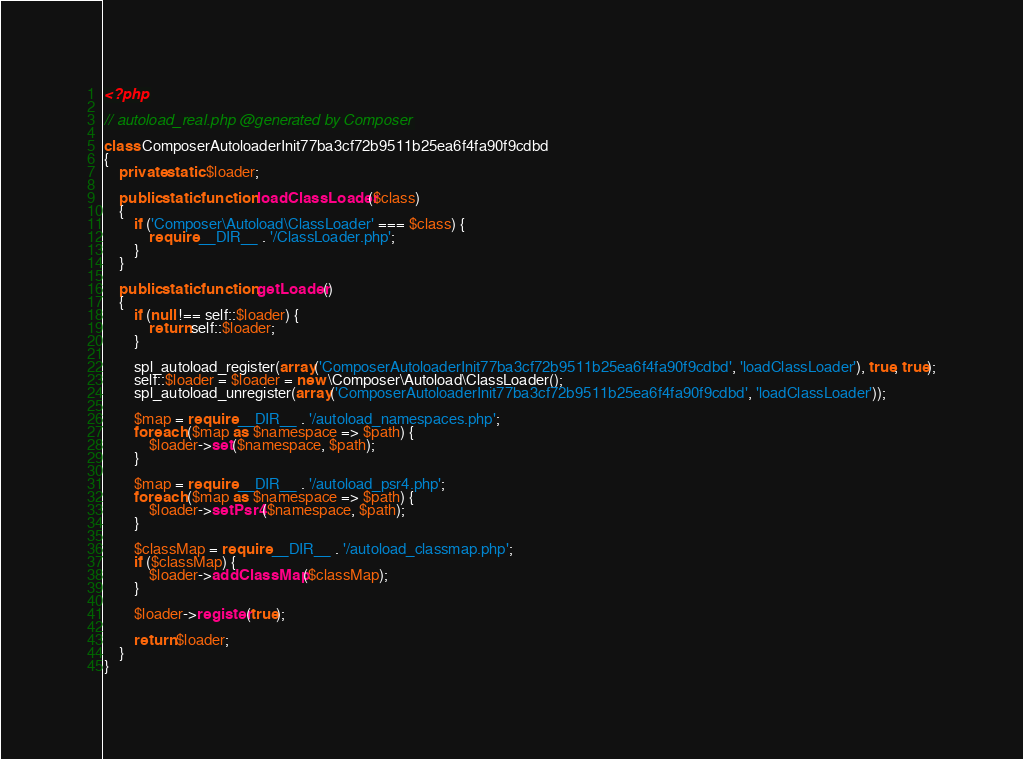<code> <loc_0><loc_0><loc_500><loc_500><_PHP_><?php

// autoload_real.php @generated by Composer

class ComposerAutoloaderInit77ba3cf72b9511b25ea6f4fa90f9cdbd
{
    private static $loader;

    public static function loadClassLoader($class)
    {
        if ('Composer\Autoload\ClassLoader' === $class) {
            require __DIR__ . '/ClassLoader.php';
        }
    }

    public static function getLoader()
    {
        if (null !== self::$loader) {
            return self::$loader;
        }

        spl_autoload_register(array('ComposerAutoloaderInit77ba3cf72b9511b25ea6f4fa90f9cdbd', 'loadClassLoader'), true, true);
        self::$loader = $loader = new \Composer\Autoload\ClassLoader();
        spl_autoload_unregister(array('ComposerAutoloaderInit77ba3cf72b9511b25ea6f4fa90f9cdbd', 'loadClassLoader'));

        $map = require __DIR__ . '/autoload_namespaces.php';
        foreach ($map as $namespace => $path) {
            $loader->set($namespace, $path);
        }

        $map = require __DIR__ . '/autoload_psr4.php';
        foreach ($map as $namespace => $path) {
            $loader->setPsr4($namespace, $path);
        }

        $classMap = require __DIR__ . '/autoload_classmap.php';
        if ($classMap) {
            $loader->addClassMap($classMap);
        }

        $loader->register(true);

        return $loader;
    }
}
</code> 